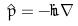<formula> <loc_0><loc_0><loc_500><loc_500>\hat { p } = - i \hbar { \nabla }</formula> 